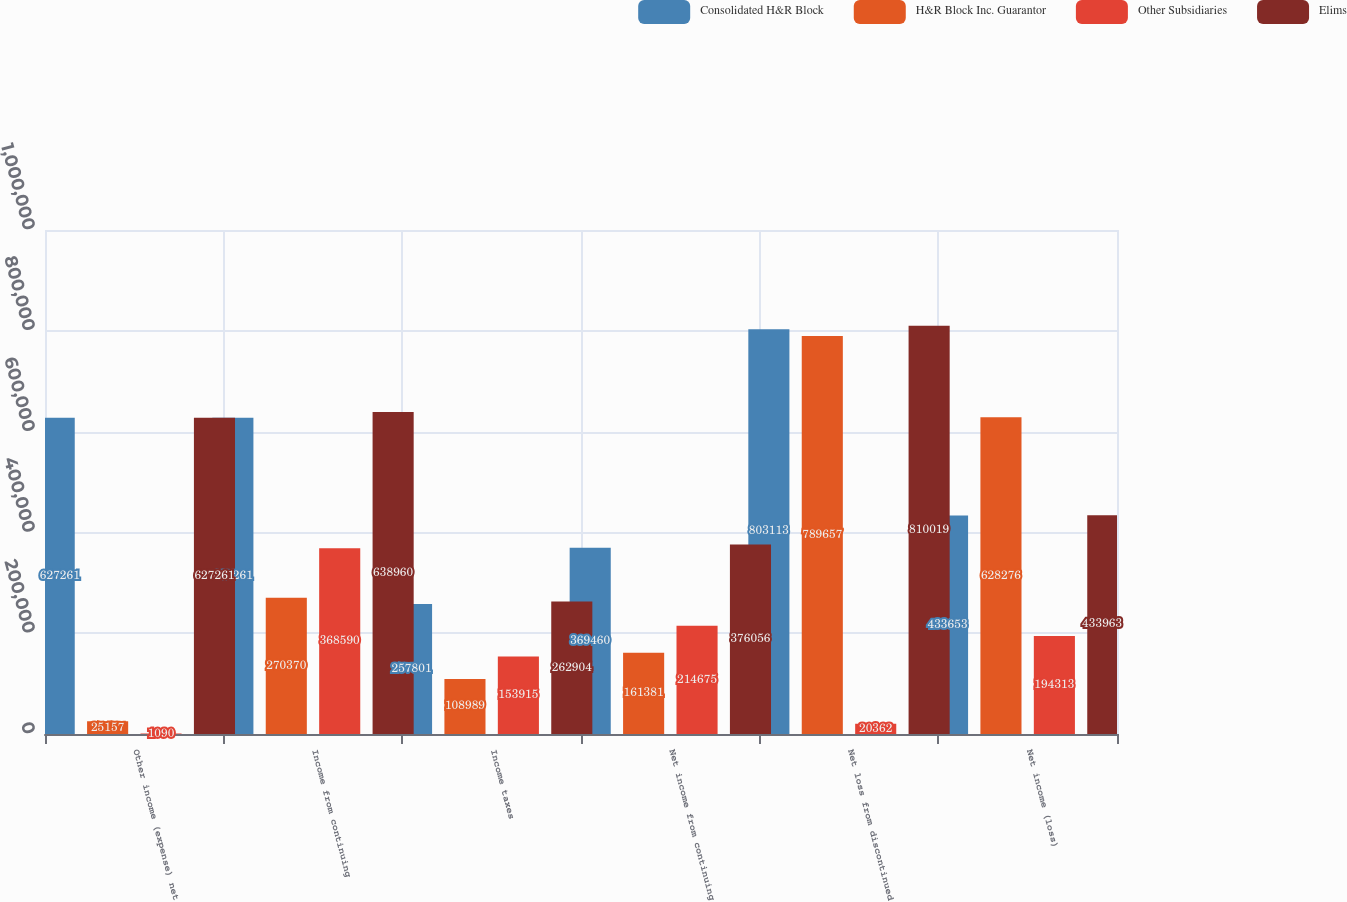<chart> <loc_0><loc_0><loc_500><loc_500><stacked_bar_chart><ecel><fcel>Other income (expense) net<fcel>Income from continuing<fcel>Income taxes<fcel>Net income from continuing<fcel>Net loss from discontinued<fcel>Net income (loss)<nl><fcel>Consolidated H&R Block<fcel>627261<fcel>627261<fcel>257801<fcel>369460<fcel>803113<fcel>433653<nl><fcel>H&R Block Inc. Guarantor<fcel>25157<fcel>270370<fcel>108989<fcel>161381<fcel>789657<fcel>628276<nl><fcel>Other Subsidiaries<fcel>1090<fcel>368590<fcel>153915<fcel>214675<fcel>20362<fcel>194313<nl><fcel>Elims<fcel>627261<fcel>638960<fcel>262904<fcel>376056<fcel>810019<fcel>433963<nl></chart> 